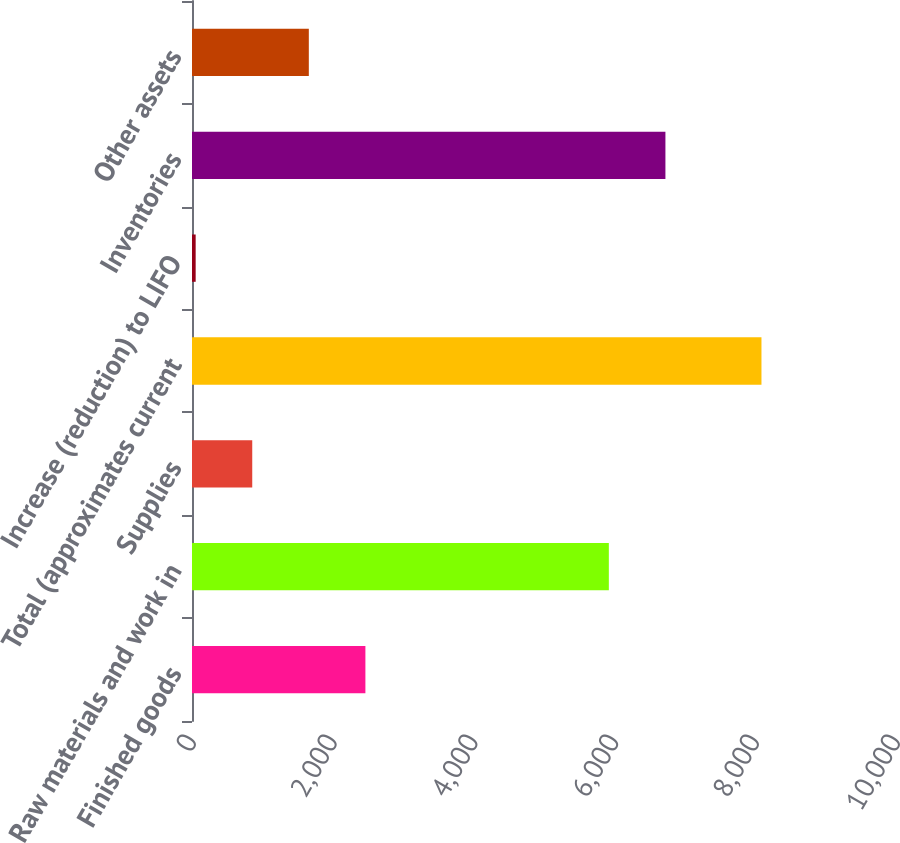<chart> <loc_0><loc_0><loc_500><loc_500><bar_chart><fcel>Finished goods<fcel>Raw materials and work in<fcel>Supplies<fcel>Total (approximates current<fcel>Increase (reduction) to LIFO<fcel>Inventories<fcel>Other assets<nl><fcel>2463.1<fcel>5921<fcel>855.7<fcel>8089<fcel>52<fcel>6724.7<fcel>1659.4<nl></chart> 